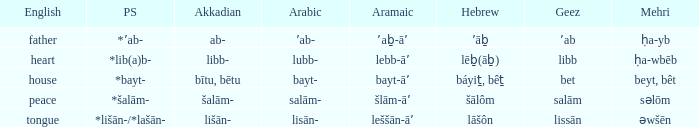If in english it is heart, what is it in hebrew? Lēḇ(āḇ). Parse the table in full. {'header': ['English', 'PS', 'Akkadian', 'Arabic', 'Aramaic', 'Hebrew', 'Geez', 'Mehri'], 'rows': [['father', '*ʼab-', 'ab-', 'ʼab-', 'ʼaḇ-āʼ', 'ʼāḇ', 'ʼab', 'ḥa-yb'], ['heart', '*lib(a)b-', 'libb-', 'lubb-', 'lebb-āʼ', 'lēḇ(āḇ)', 'libb', 'ḥa-wbēb'], ['house', '*bayt-', 'bītu, bētu', 'bayt-', 'bayt-āʼ', 'báyiṯ, bêṯ', 'bet', 'beyt, bêt'], ['peace', '*šalām-', 'šalām-', 'salām-', 'šlām-āʼ', 'šālôm', 'salām', 'səlōm'], ['tongue', '*lišān-/*lašān-', 'lišān-', 'lisān-', 'leššān-āʼ', 'lāšôn', 'lissān', 'əwšēn']]} 